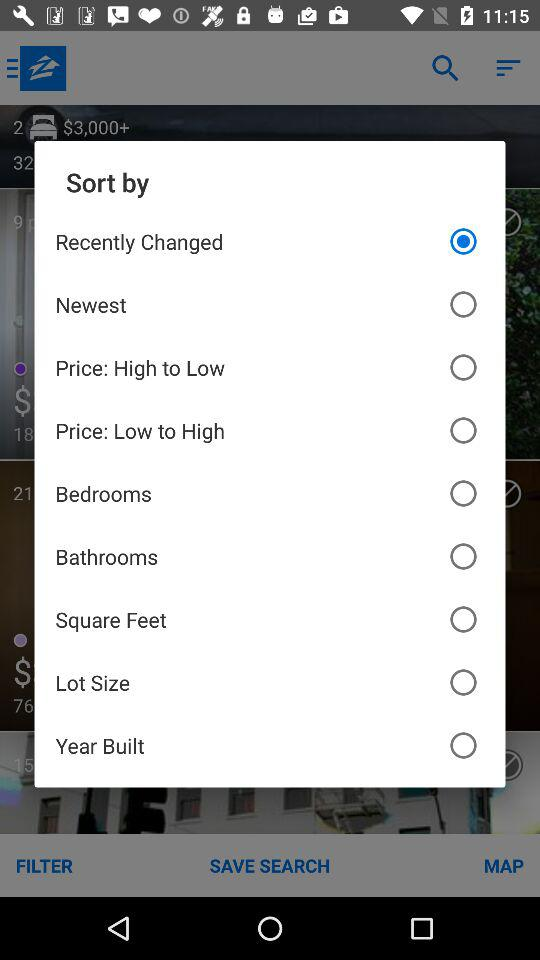Which option is selected? The selected option is "Recently Changed". 